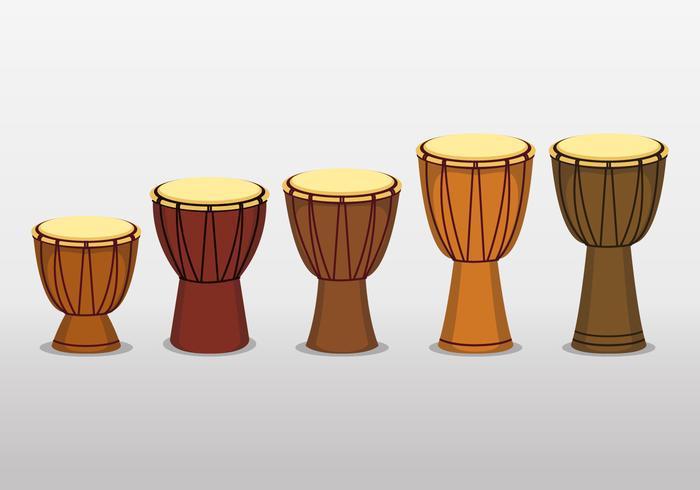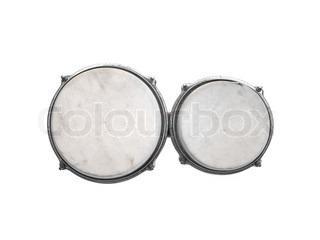The first image is the image on the left, the second image is the image on the right. For the images shown, is this caption "There are twice as many drums in the image on the right." true? Answer yes or no. No. 